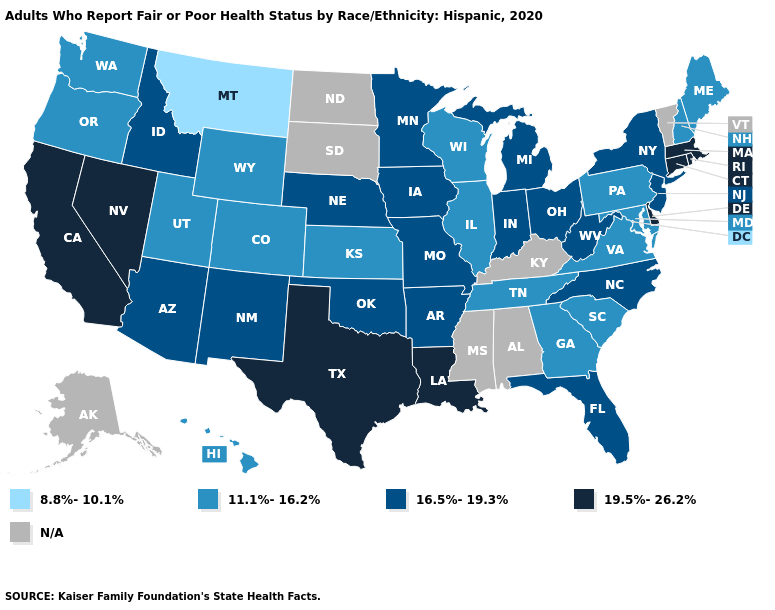Name the states that have a value in the range 19.5%-26.2%?
Concise answer only. California, Connecticut, Delaware, Louisiana, Massachusetts, Nevada, Rhode Island, Texas. What is the highest value in the USA?
Short answer required. 19.5%-26.2%. Does Montana have the lowest value in the West?
Concise answer only. Yes. What is the value of North Carolina?
Give a very brief answer. 16.5%-19.3%. Name the states that have a value in the range 16.5%-19.3%?
Write a very short answer. Arizona, Arkansas, Florida, Idaho, Indiana, Iowa, Michigan, Minnesota, Missouri, Nebraska, New Jersey, New Mexico, New York, North Carolina, Ohio, Oklahoma, West Virginia. What is the lowest value in the USA?
Be succinct. 8.8%-10.1%. Among the states that border Missouri , which have the highest value?
Give a very brief answer. Arkansas, Iowa, Nebraska, Oklahoma. What is the highest value in the South ?
Short answer required. 19.5%-26.2%. What is the value of South Dakota?
Quick response, please. N/A. Does the first symbol in the legend represent the smallest category?
Concise answer only. Yes. Among the states that border South Carolina , does North Carolina have the highest value?
Short answer required. Yes. Name the states that have a value in the range 19.5%-26.2%?
Answer briefly. California, Connecticut, Delaware, Louisiana, Massachusetts, Nevada, Rhode Island, Texas. Name the states that have a value in the range 16.5%-19.3%?
Answer briefly. Arizona, Arkansas, Florida, Idaho, Indiana, Iowa, Michigan, Minnesota, Missouri, Nebraska, New Jersey, New Mexico, New York, North Carolina, Ohio, Oklahoma, West Virginia. Does the first symbol in the legend represent the smallest category?
Concise answer only. Yes. Does the first symbol in the legend represent the smallest category?
Give a very brief answer. Yes. 